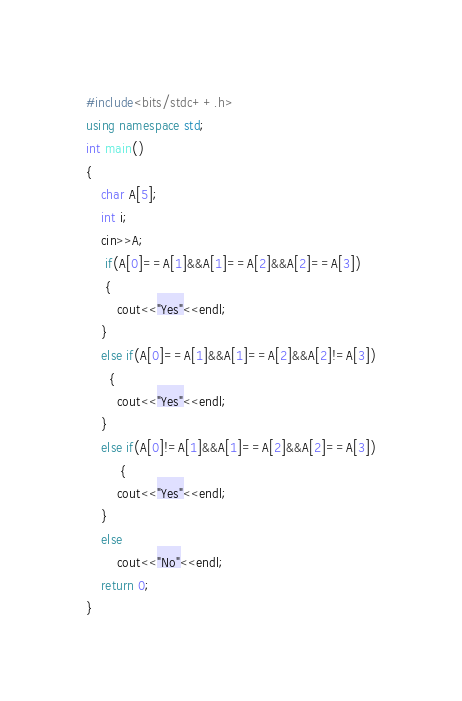Convert code to text. <code><loc_0><loc_0><loc_500><loc_500><_C++_>#include<bits/stdc++.h>
using namespace std;
int main()
{
    char A[5];
    int i;
    cin>>A;
     if(A[0]==A[1]&&A[1]==A[2]&&A[2]==A[3])
     {
        cout<<"Yes"<<endl;
    }
    else if(A[0]==A[1]&&A[1]==A[2]&&A[2]!=A[3])
      {
        cout<<"Yes"<<endl;
    }
    else if(A[0]!=A[1]&&A[1]==A[2]&&A[2]==A[3])
         {
        cout<<"Yes"<<endl;
    }
    else
        cout<<"No"<<endl;
    return 0;
}</code> 